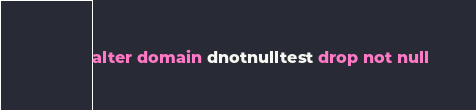<code> <loc_0><loc_0><loc_500><loc_500><_SQL_>alter domain dnotnulltest drop not null
</code> 